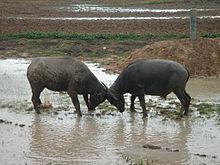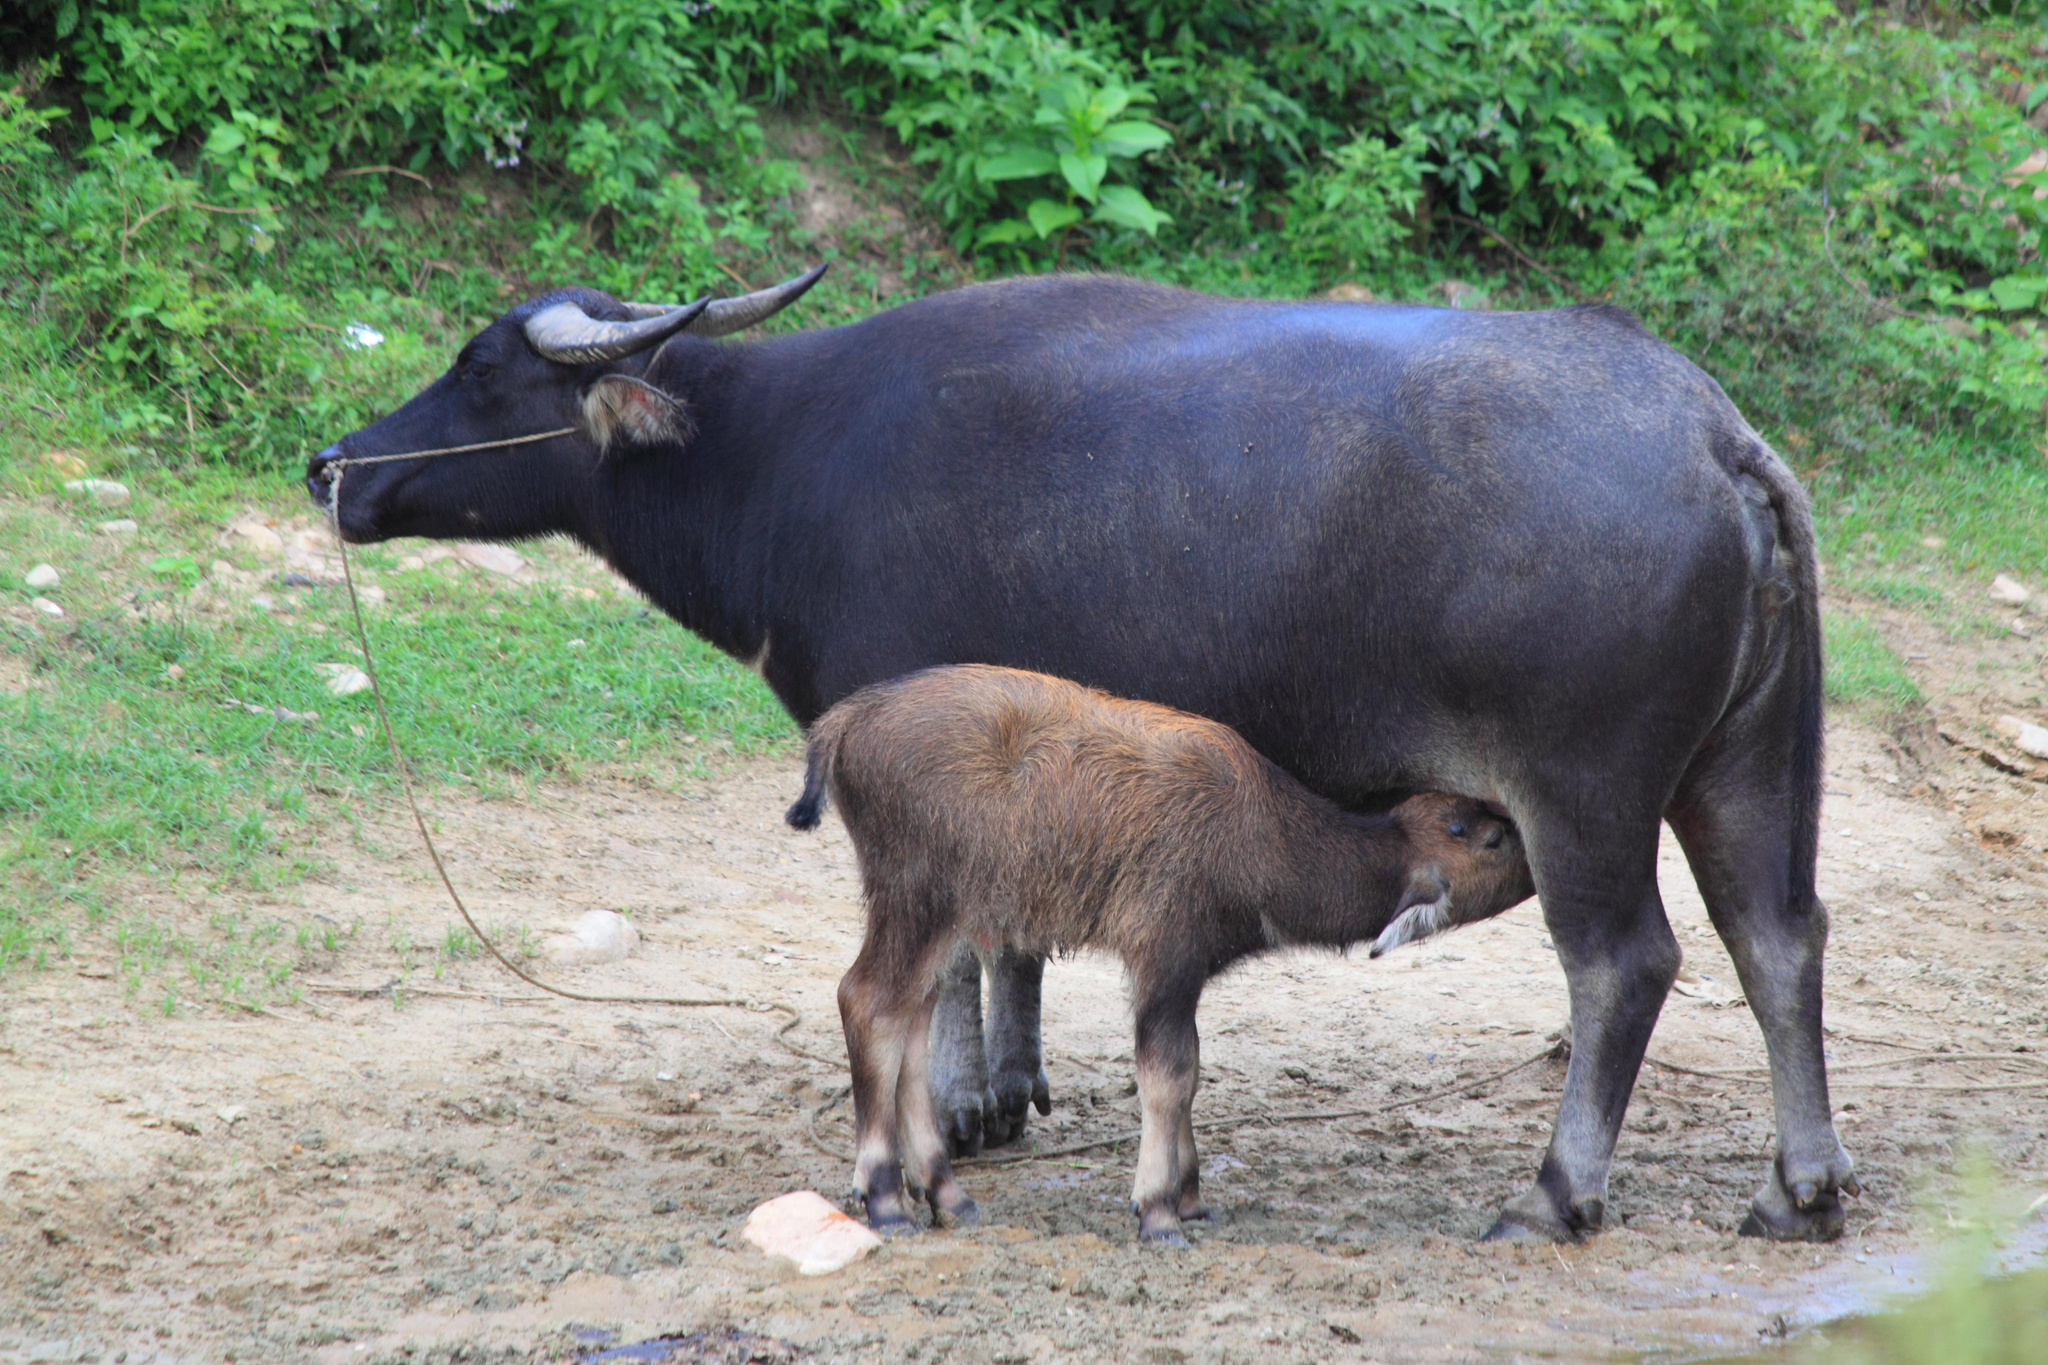The first image is the image on the left, the second image is the image on the right. Evaluate the accuracy of this statement regarding the images: "One of the images contains one baby water buffalo.". Is it true? Answer yes or no. Yes. 